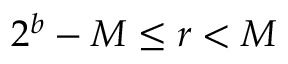<formula> <loc_0><loc_0><loc_500><loc_500>2 ^ { b } - M \leq r < M</formula> 